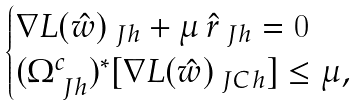<formula> <loc_0><loc_0><loc_500><loc_500>\begin{cases} \nabla L ( \hat { w } ) _ { \ J h } + \mu \, \hat { r } _ { \ J h } = 0 \\ ( \Omega _ { \ J h } ^ { c } ) ^ { \ast } [ \nabla L ( \hat { w } ) _ { \ J C h } ] \leq \mu , \end{cases}</formula> 